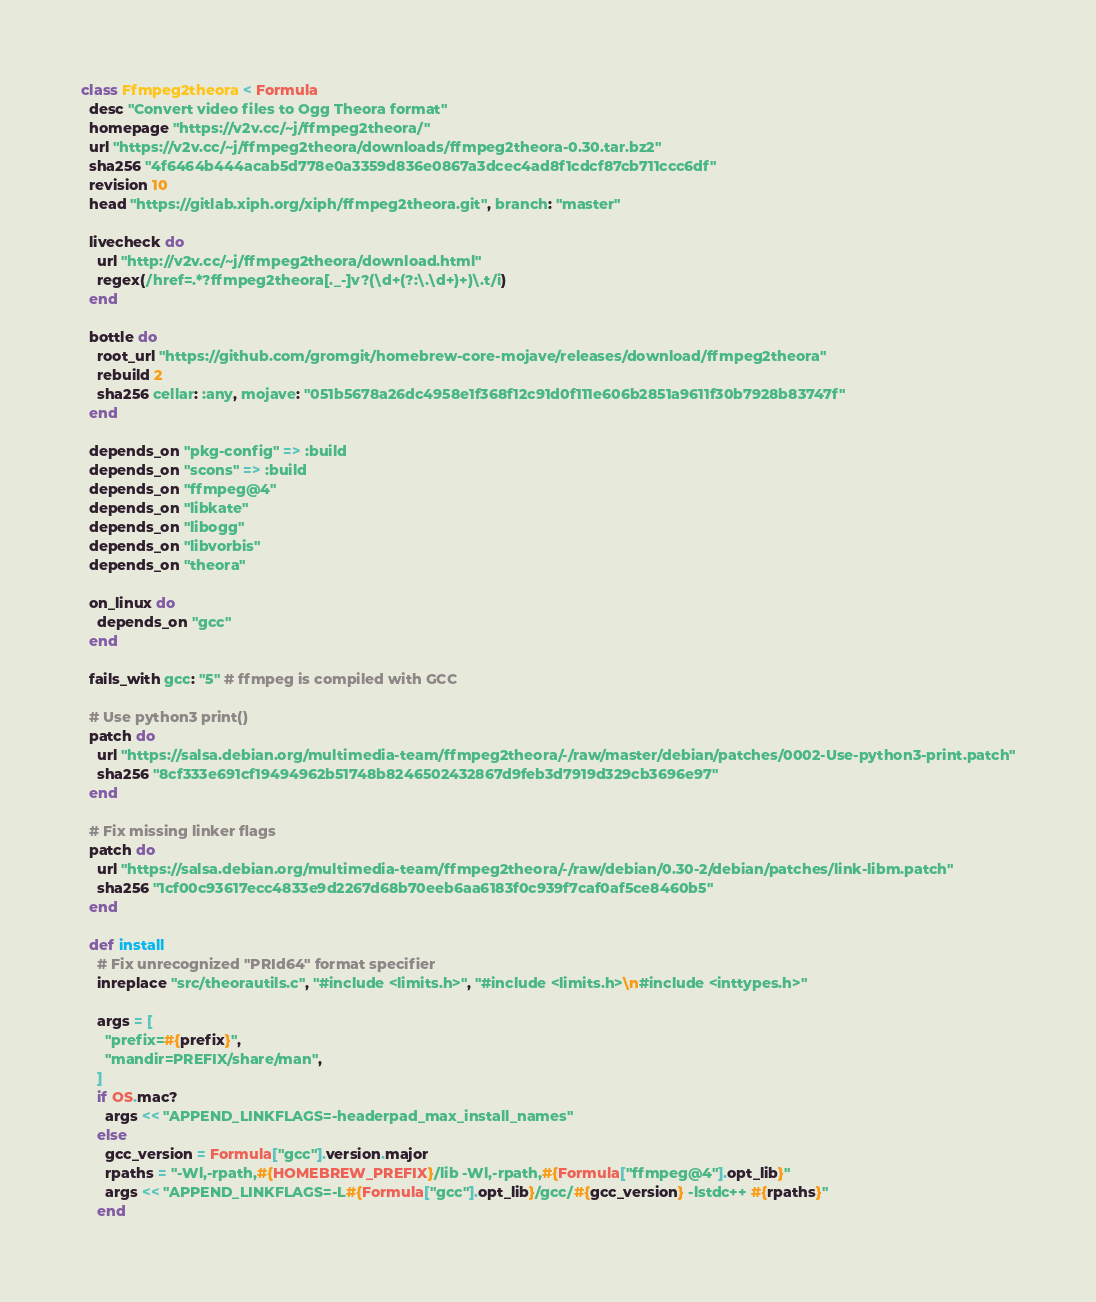<code> <loc_0><loc_0><loc_500><loc_500><_Ruby_>class Ffmpeg2theora < Formula
  desc "Convert video files to Ogg Theora format"
  homepage "https://v2v.cc/~j/ffmpeg2theora/"
  url "https://v2v.cc/~j/ffmpeg2theora/downloads/ffmpeg2theora-0.30.tar.bz2"
  sha256 "4f6464b444acab5d778e0a3359d836e0867a3dcec4ad8f1cdcf87cb711ccc6df"
  revision 10
  head "https://gitlab.xiph.org/xiph/ffmpeg2theora.git", branch: "master"

  livecheck do
    url "http://v2v.cc/~j/ffmpeg2theora/download.html"
    regex(/href=.*?ffmpeg2theora[._-]v?(\d+(?:\.\d+)+)\.t/i)
  end

  bottle do
    root_url "https://github.com/gromgit/homebrew-core-mojave/releases/download/ffmpeg2theora"
    rebuild 2
    sha256 cellar: :any, mojave: "051b5678a26dc4958e1f368f12c91d0f111e606b2851a9611f30b7928b83747f"
  end

  depends_on "pkg-config" => :build
  depends_on "scons" => :build
  depends_on "ffmpeg@4"
  depends_on "libkate"
  depends_on "libogg"
  depends_on "libvorbis"
  depends_on "theora"

  on_linux do
    depends_on "gcc"
  end

  fails_with gcc: "5" # ffmpeg is compiled with GCC

  # Use python3 print()
  patch do
    url "https://salsa.debian.org/multimedia-team/ffmpeg2theora/-/raw/master/debian/patches/0002-Use-python3-print.patch"
    sha256 "8cf333e691cf19494962b51748b8246502432867d9feb3d7919d329cb3696e97"
  end

  # Fix missing linker flags
  patch do
    url "https://salsa.debian.org/multimedia-team/ffmpeg2theora/-/raw/debian/0.30-2/debian/patches/link-libm.patch"
    sha256 "1cf00c93617ecc4833e9d2267d68b70eeb6aa6183f0c939f7caf0af5ce8460b5"
  end

  def install
    # Fix unrecognized "PRId64" format specifier
    inreplace "src/theorautils.c", "#include <limits.h>", "#include <limits.h>\n#include <inttypes.h>"

    args = [
      "prefix=#{prefix}",
      "mandir=PREFIX/share/man",
    ]
    if OS.mac?
      args << "APPEND_LINKFLAGS=-headerpad_max_install_names"
    else
      gcc_version = Formula["gcc"].version.major
      rpaths = "-Wl,-rpath,#{HOMEBREW_PREFIX}/lib -Wl,-rpath,#{Formula["ffmpeg@4"].opt_lib}"
      args << "APPEND_LINKFLAGS=-L#{Formula["gcc"].opt_lib}/gcc/#{gcc_version} -lstdc++ #{rpaths}"
    end</code> 